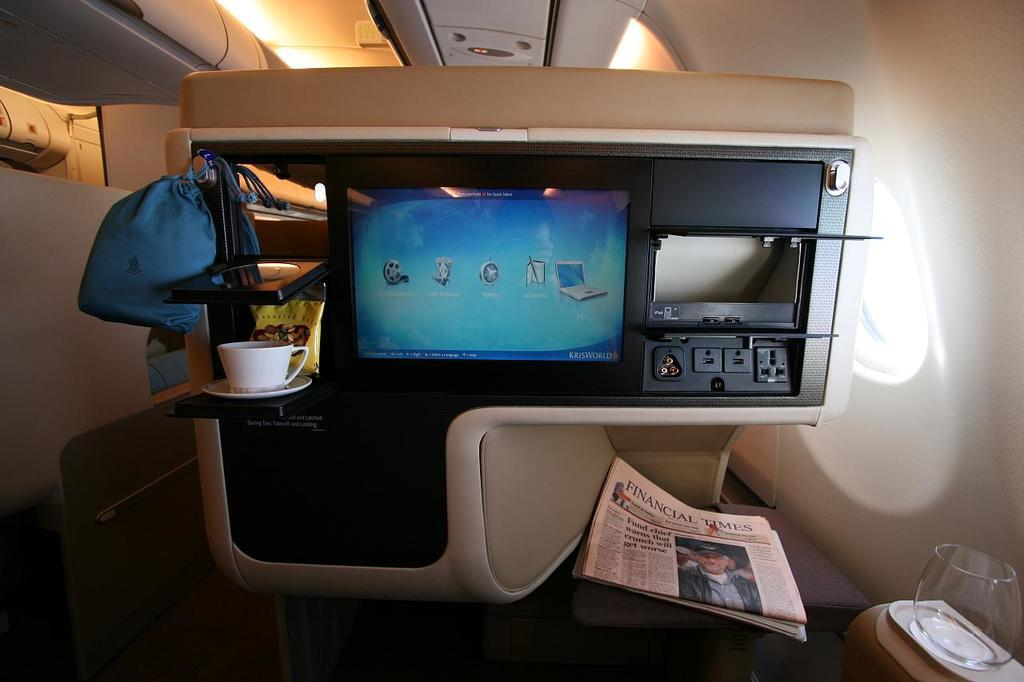<image>
Render a clear and concise summary of the photo. In a luxury airline seat there is a Financial Times newspaper. 